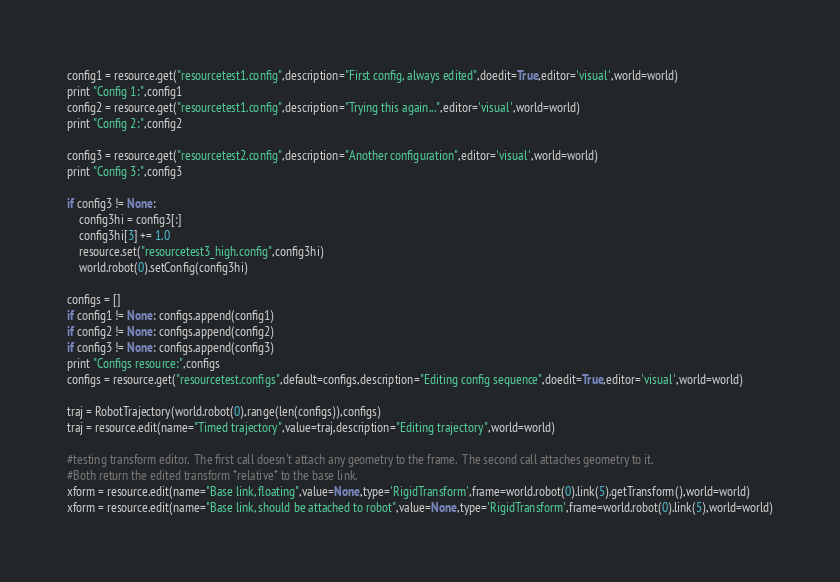<code> <loc_0><loc_0><loc_500><loc_500><_Python_>config1 = resource.get("resourcetest1.config",description="First config, always edited",doedit=True,editor='visual',world=world)
print "Config 1:",config1
config2 = resource.get("resourcetest1.config",description="Trying this again...",editor='visual',world=world)
print "Config 2:",config2

config3 = resource.get("resourcetest2.config",description="Another configuration",editor='visual',world=world)
print "Config 3:",config3

if config3 != None:
    config3hi = config3[:]
    config3hi[3] += 1.0
    resource.set("resourcetest3_high.config",config3hi)
    world.robot(0).setConfig(config3hi)

configs = []
if config1 != None: configs.append(config1)
if config2 != None: configs.append(config2)
if config3 != None: configs.append(config3)
print "Configs resource:",configs
configs = resource.get("resourcetest.configs",default=configs,description="Editing config sequence",doedit=True,editor='visual',world=world)

traj = RobotTrajectory(world.robot(0),range(len(configs)),configs)
traj = resource.edit(name="Timed trajectory",value=traj,description="Editing trajectory",world=world)

#testing transform editor.  The first call doesn't attach any geometry to the frame.  The second call attaches geometry to it.
#Both return the edited transform *relative* to the base link.
xform = resource.edit(name="Base link, floating",value=None,type='RigidTransform',frame=world.robot(0).link(5).getTransform(),world=world)
xform = resource.edit(name="Base link, should be attached to robot",value=None,type='RigidTransform',frame=world.robot(0).link(5),world=world)

</code> 